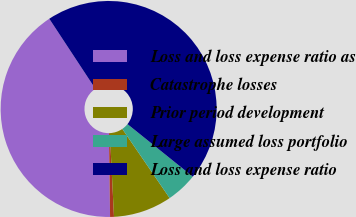Convert chart to OTSL. <chart><loc_0><loc_0><loc_500><loc_500><pie_chart><fcel>Loss and loss expense ratio as<fcel>Catastrophe losses<fcel>Prior period development<fcel>Large assumed loss portfolio<fcel>Loss and loss expense ratio<nl><fcel>40.95%<fcel>0.58%<fcel>8.76%<fcel>4.67%<fcel>45.04%<nl></chart> 